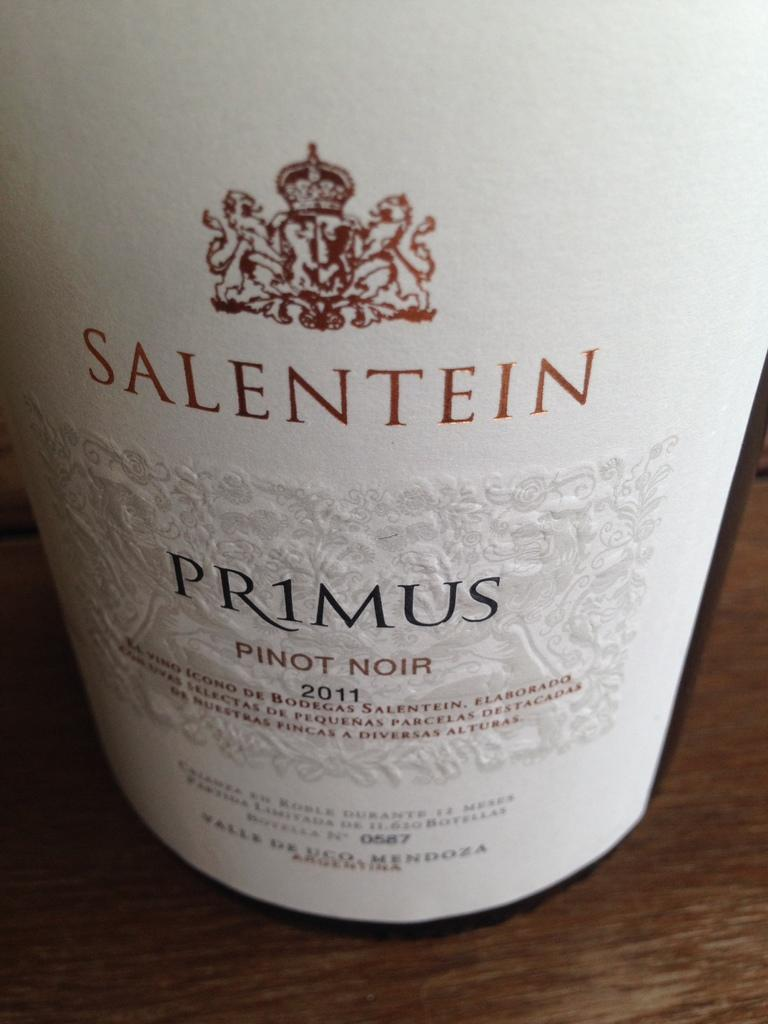<image>
Provide a brief description of the given image. A bottle is dated with the year 2011. 